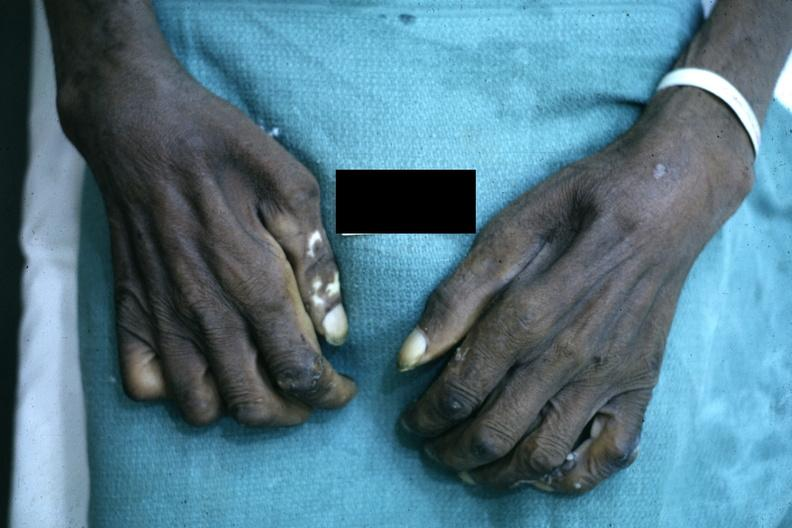re good example tastefully shown with face out of picture and genitalia present?
Answer the question using a single word or phrase. No 